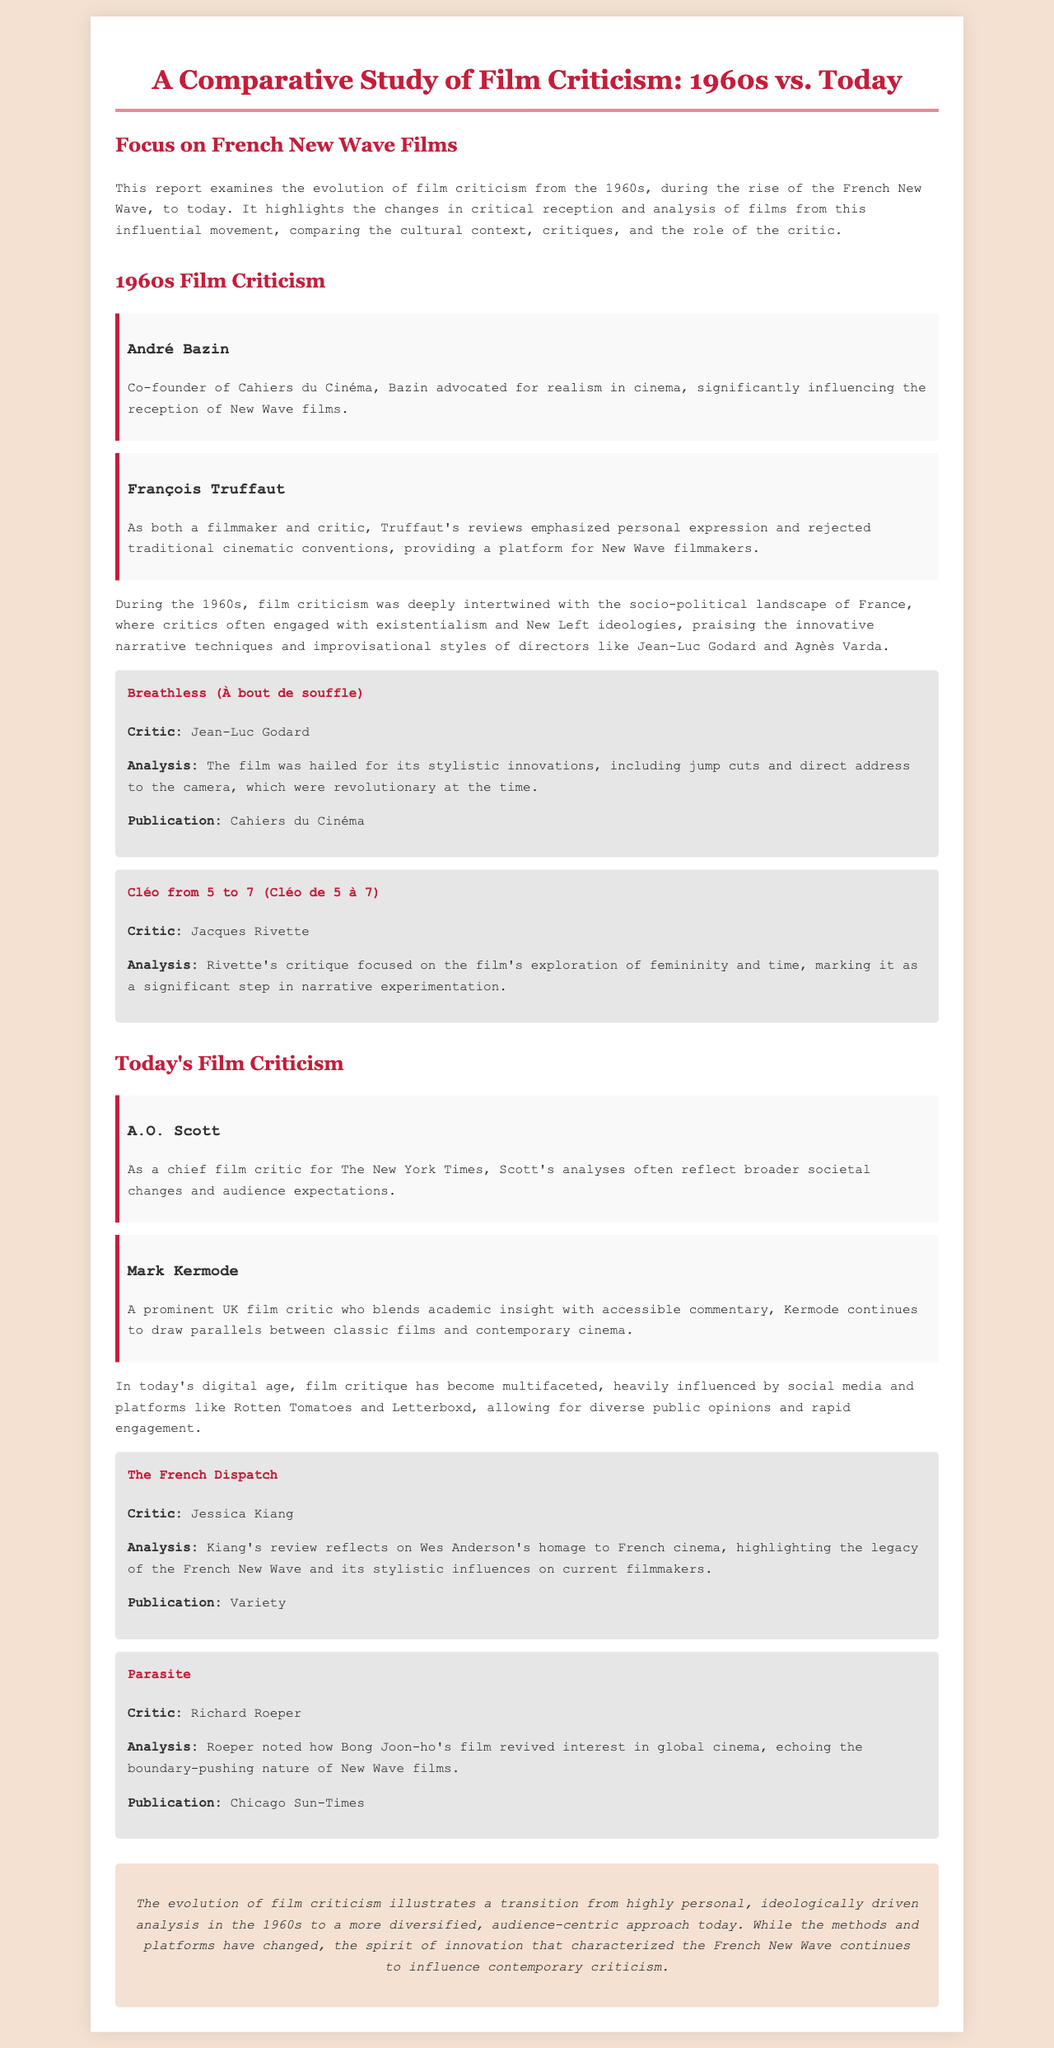What was the title of André Bazin's influential publication? André Bazin co-founded Cahiers du Cinéma, which is highlighted in the document.
Answer: Cahiers du Cinéma Who is a prominent chief film critic for The New York Times today? The document mentions A.O. Scott as the chief film critic for The New York Times.
Answer: A.O. Scott What is the focus of Jacques Rivette's critique of Cléo from 5 to 7? Rivette focused on the film's exploration of femininity and time, as noted in the document.
Answer: Femininity and time In what year did the French New Wave rise? The document references the 1960s as the period of the French New Wave's rise.
Answer: 1960s Which film did Jessica Kiang review that pays homage to French cinema? The document mentions The French Dispatch as the film reviewed by Jessica Kiang.
Answer: The French Dispatch What is one major change in film criticism from the 1960s to today? The document states that film criticism has evolved from being ideologically driven to a more audience-centric approach.
Answer: Audience-centric approach Who provided an analysis for the film Parasite? Richard Roeper is noted in the document as the critic who analyzed the film Parasite.
Answer: Richard Roeper What publication featured a review of Breathless (À bout de souffle)? The document lists Cahiers du Cinéma as the publication for the review of Breathless.
Answer: Cahiers du Cinéma 